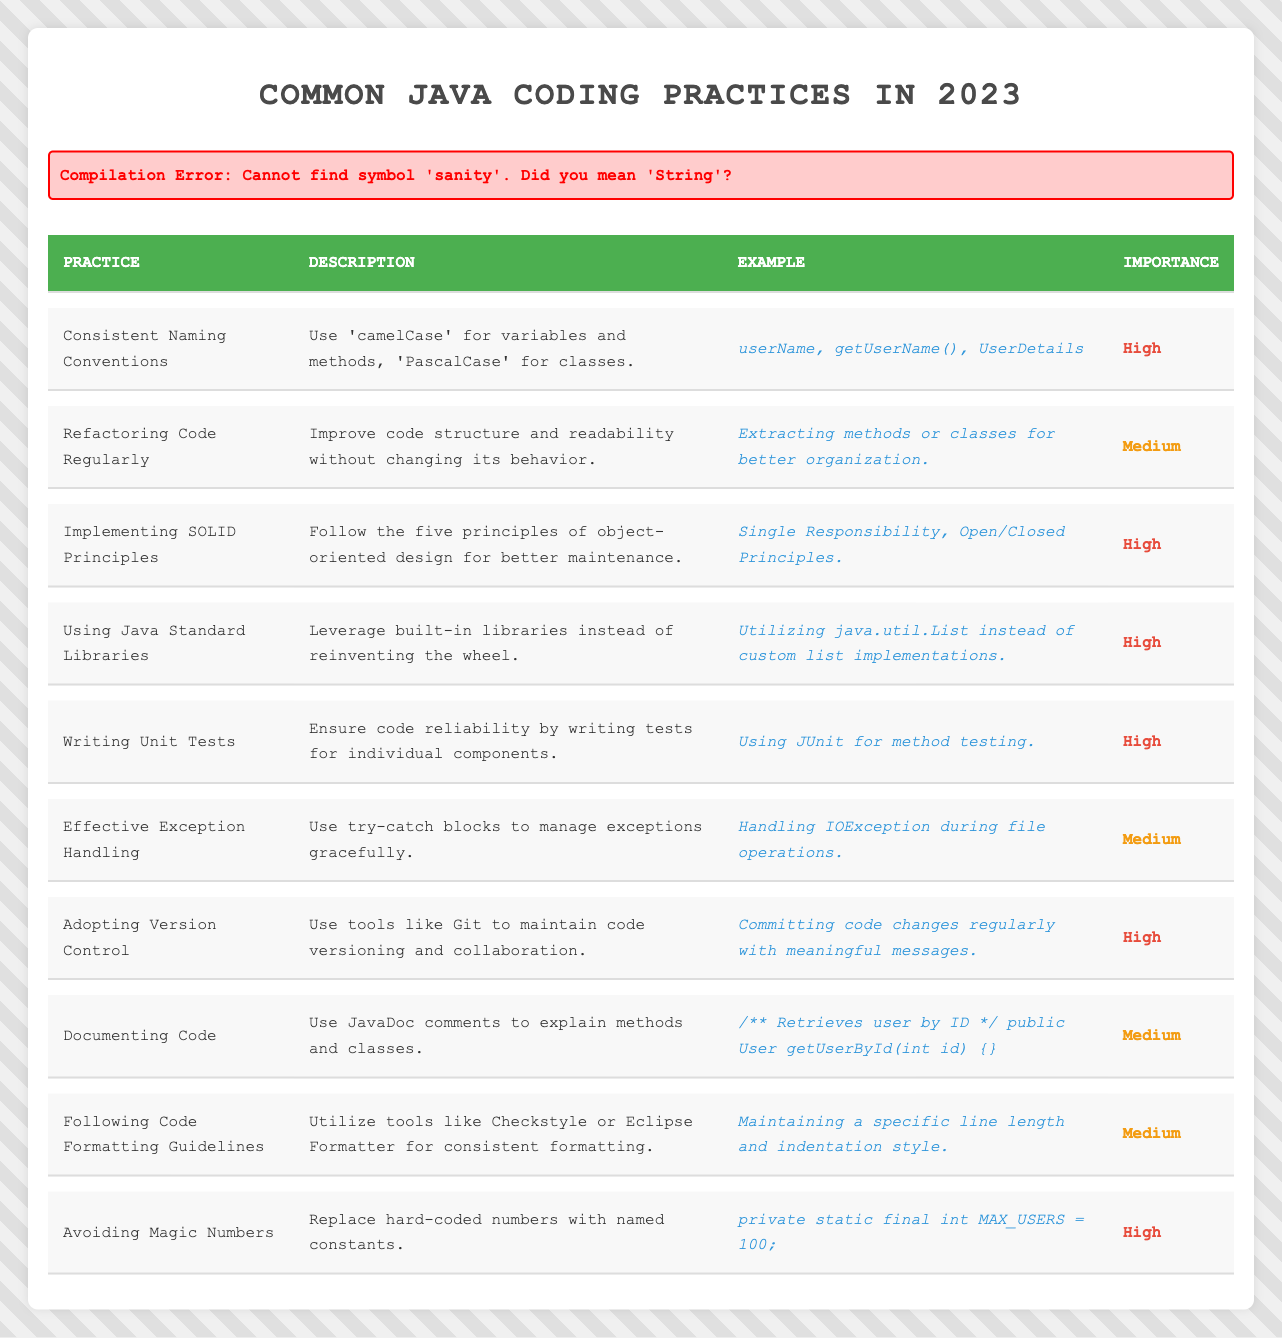What is the importance level of "Writing Unit Tests"? By looking at the table, I can find the row for "Writing Unit Tests," which indicates the importance level given as **High**.
Answer: High How many practices have a **Medium** importance level? The table shows three practices listed with a **Medium** importance level: "Refactoring Code Regularly," "Effective Exception Handling," and "Documenting Code." Therefore, the count is 3.
Answer: 3 Which practice involves using built-in libraries? The table indicates that "Using Java Standard Libraries" describes leveraging built-in libraries instead of creating custom solutions.
Answer: Using Java Standard Libraries Is "Consistent Naming Conventions" labeled as high importance? Observing the table reveals that "Consistent Naming Conventions" is indeed marked as **High** in importance.
Answer: Yes Which practices have the highest importance? Referring to the table, the practices with **High** importance include "Consistent Naming Conventions," "Implementing SOLID Principles," "Using Java Standard Libraries," "Writing Unit Tests," "Adopting Version Control," and "Avoiding Magic Numbers." Therefore, there are 6 practices with high importance.
Answer: 6 What are the differences in importance levels between the practices with high and medium importance? By checking the table, I see that 6 practices are marked as **High** importance, and 4 practices are marked as **Medium** importance. The difference is 6 - 4 = 2.
Answer: 2 Are there more practices in the table labeled "High" or "Medium"? There are 6 practices with **High** importance and 4 practices with **Medium** importance. Therefore, there are more practices labeled "High."
Answer: High What percentage of practices are considered **High** importance? Counting the total number of practices in the table, there are 10. Since 6 of them have **High** importance, the percentage is (6/10) * 100 = 60%.
Answer: 60% Which practice has the lowest importance level? Based on the table, the practices with **Medium** importance level all have equal importance, but there are no practices labeled as **Low**, meaning the lowest importance is **Medium**.
Answer: Medium Which practice emphasizes the extraction of methods or classes for better organization? The table notes that "Refactoring Code Regularly" stresses the importance of extracting methods or classes to improve code organization.
Answer: Refactoring Code Regularly 